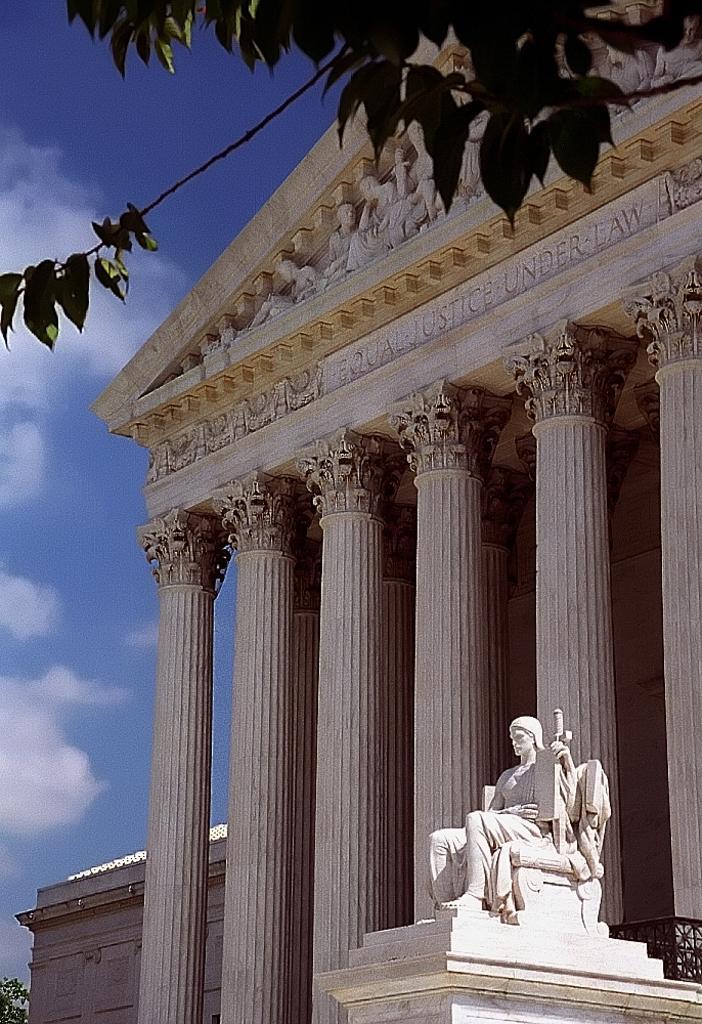Can you describe this image briefly? In this image we can see a building and there is a sculpture in front of the building and we can see some leaves at the top of the picture. We can see there is a tree on the left side and we can see the sky with clouds. 